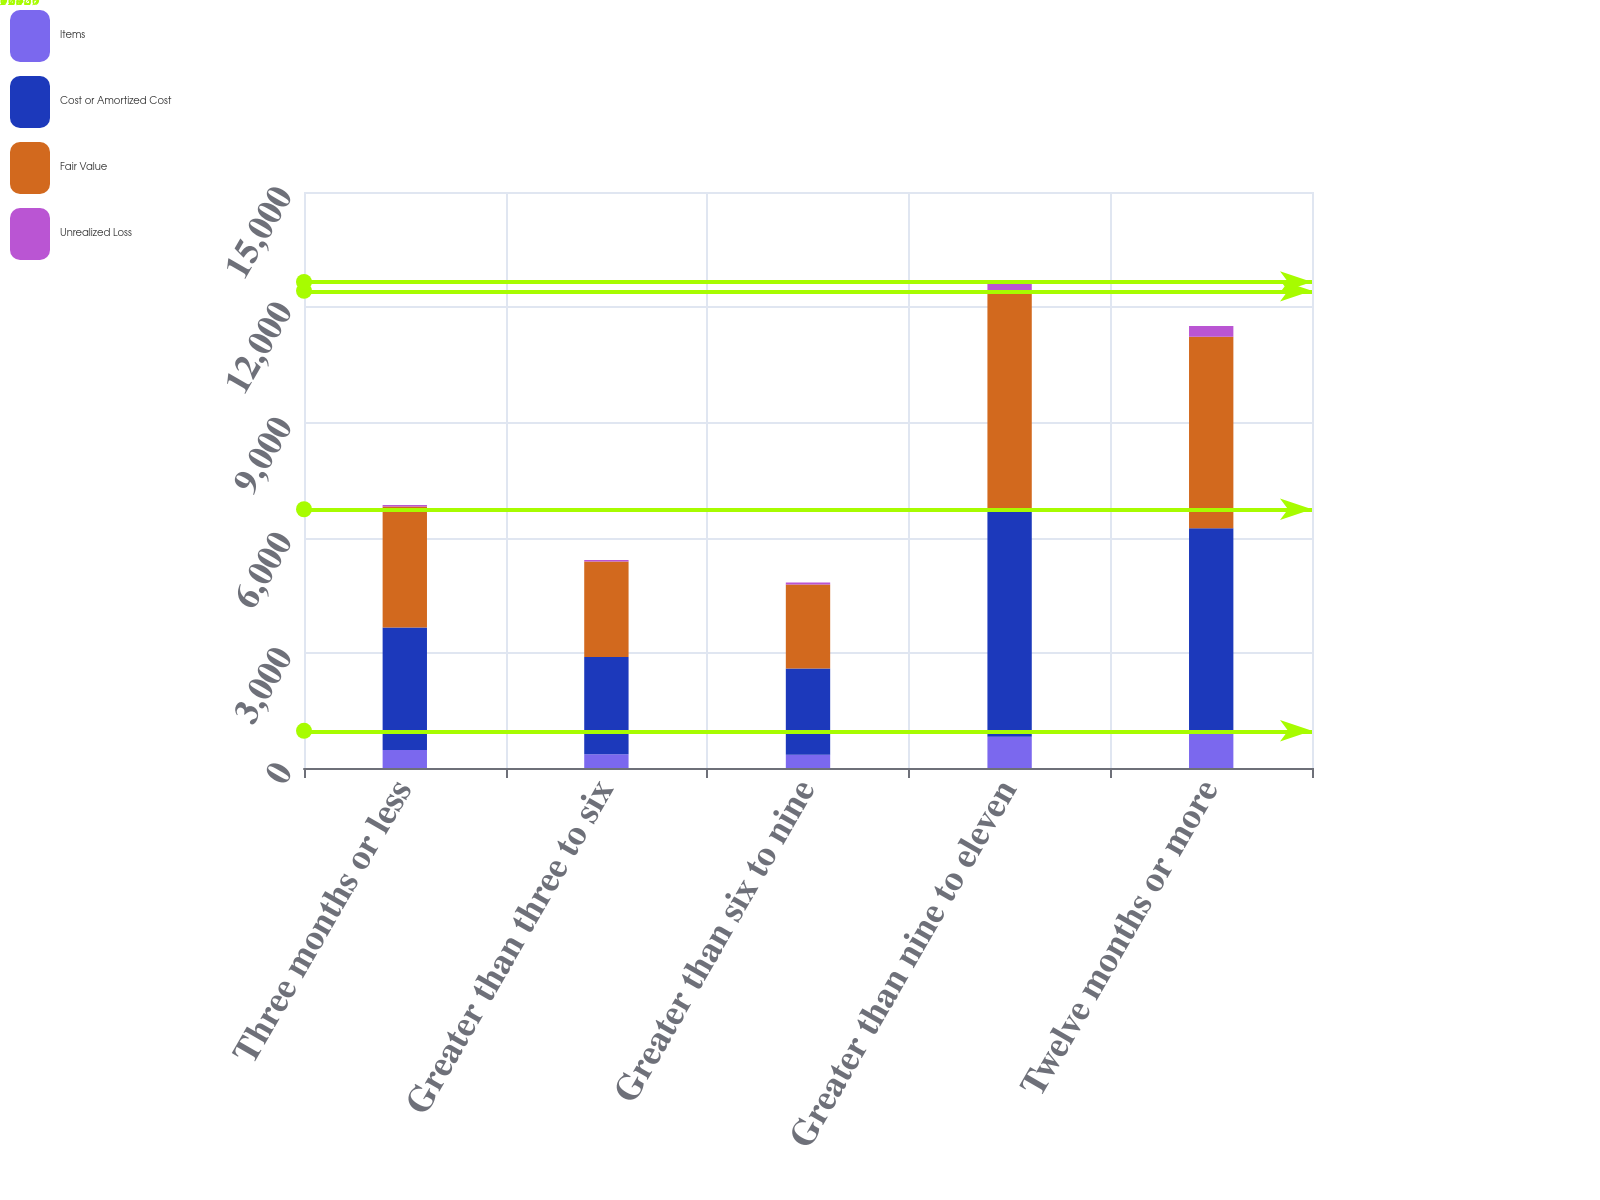<chart> <loc_0><loc_0><loc_500><loc_500><stacked_bar_chart><ecel><fcel>Three months or less<fcel>Greater than three to six<fcel>Greater than six to nine<fcel>Greater than nine to eleven<fcel>Twelve months or more<nl><fcel>Items<fcel>468<fcel>359<fcel>347<fcel>817<fcel>969<nl><fcel>Cost or Amortized Cost<fcel>3191<fcel>2530<fcel>2243<fcel>5921<fcel>5272<nl><fcel>Fair Value<fcel>3153<fcel>2487<fcel>2186<fcel>5688<fcel>4989<nl><fcel>Unrealized Loss<fcel>38<fcel>43<fcel>57<fcel>233<fcel>283<nl></chart> 